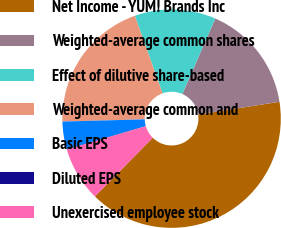Convert chart. <chart><loc_0><loc_0><loc_500><loc_500><pie_chart><fcel>Net Income - YUM! Brands Inc<fcel>Weighted-average common shares<fcel>Effect of dilutive share-based<fcel>Weighted-average common and<fcel>Basic EPS<fcel>Diluted EPS<fcel>Unexercised employee stock<nl><fcel>39.84%<fcel>15.99%<fcel>12.01%<fcel>19.96%<fcel>4.06%<fcel>0.09%<fcel>8.04%<nl></chart> 